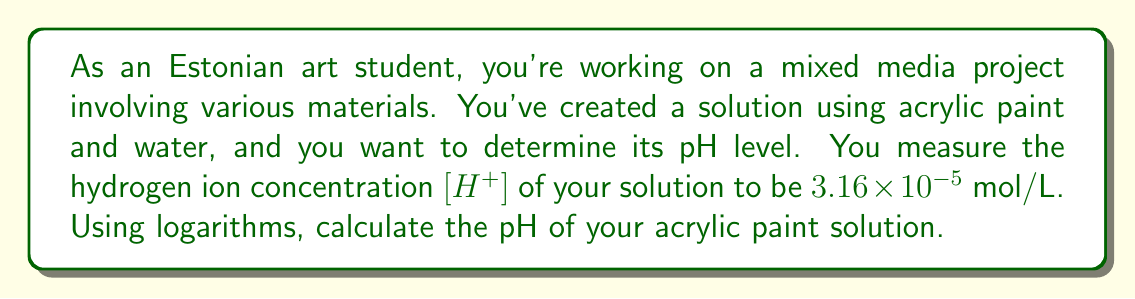Can you solve this math problem? To solve this problem, we'll use the definition of pH and the properties of logarithms:

1) The pH is defined as the negative logarithm (base 10) of the hydrogen ion concentration:

   $$ pH = -\log_{10}[H^+] $$

2) We're given that $[H^+] = 3.16 \times 10^{-5}$ mol/L

3) Substituting this into our equation:

   $$ pH = -\log_{10}(3.16 \times 10^{-5}) $$

4) Using the properties of logarithms, we can split this into two parts:

   $$ pH = -(\log_{10}(3.16) + \log_{10}(10^{-5})) $$

5) We know that $\log_{10}(10^x) = x$, so:

   $$ pH = -(\log_{10}(3.16) - 5) $$

6) Using a calculator or logarithm tables:

   $$ pH = -(0.4997 - 5) $$

7) Simplifying:

   $$ pH = -0.4997 + 5 = 4.5003 $$

8) Rounding to two decimal places, as is common for pH values:

   $$ pH = 4.50 $$
Answer: The pH of the acrylic paint solution is 4.50. 